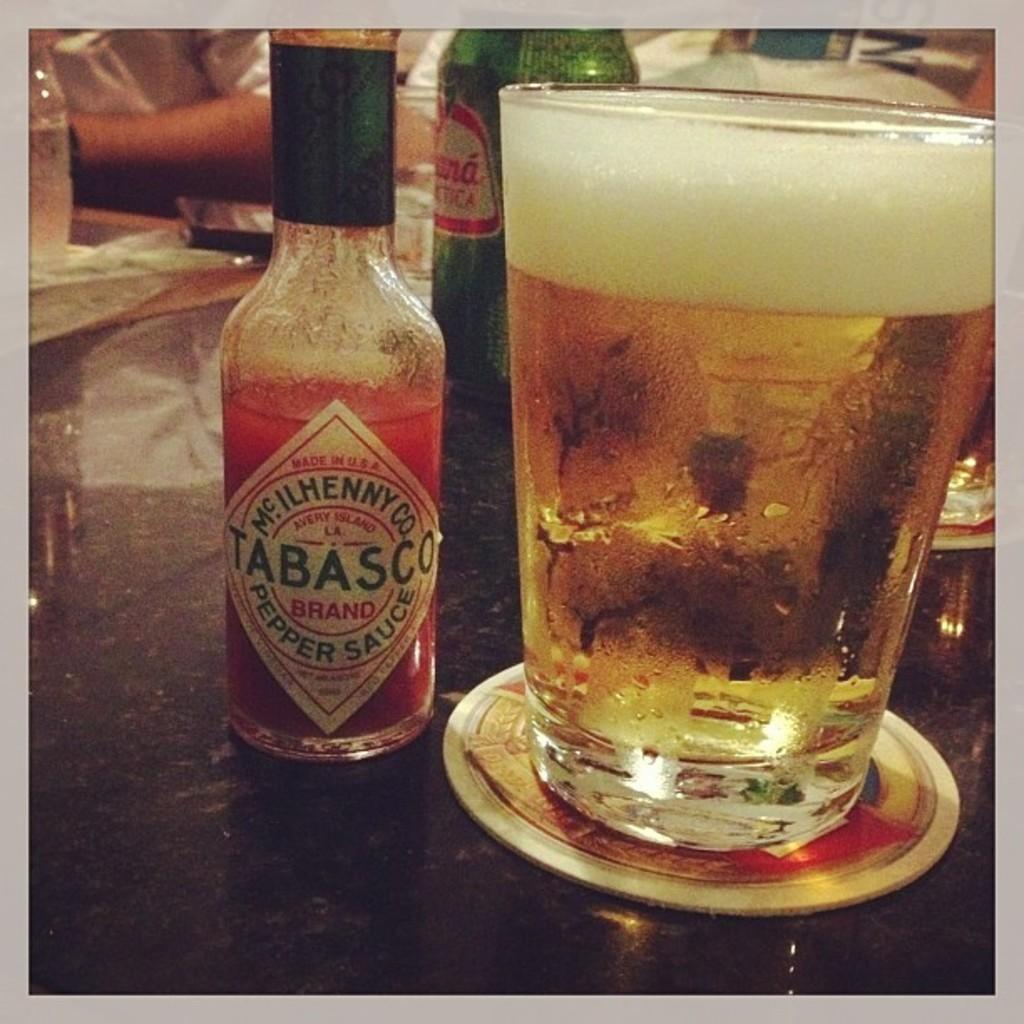What is the brand on the bottle?
Your answer should be compact. Tabasco. What company makes the tabasco?
Ensure brevity in your answer.  Mc ilhenny co. 